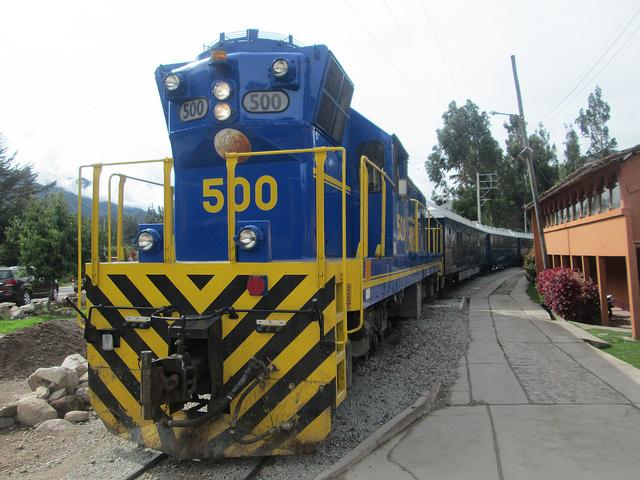What number is on the blue train?
Concise answer only. 500. What color is the front of the train?
Concise answer only. Blue. What colors make up the train?
Keep it brief. Blue yellow black. Is this a passenger train?
Concise answer only. Yes. 